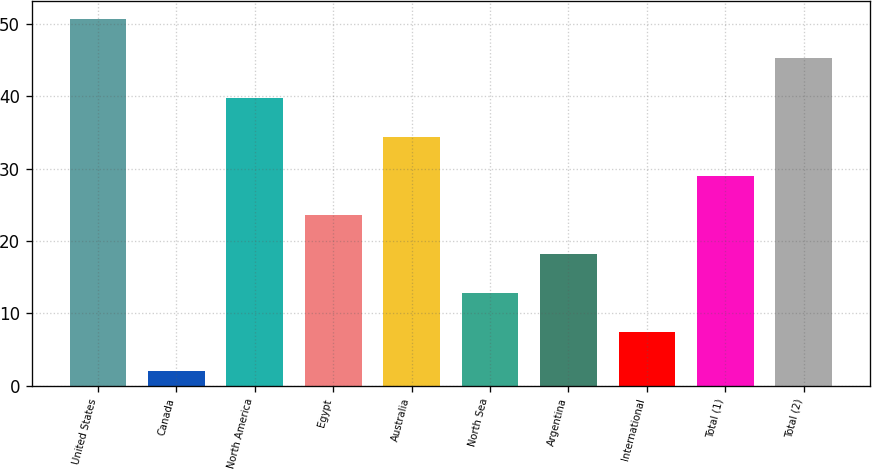Convert chart. <chart><loc_0><loc_0><loc_500><loc_500><bar_chart><fcel>United States<fcel>Canada<fcel>North America<fcel>Egypt<fcel>Australia<fcel>North Sea<fcel>Argentina<fcel>International<fcel>Total (1)<fcel>Total (2)<nl><fcel>50.6<fcel>2<fcel>39.8<fcel>23.6<fcel>34.4<fcel>12.8<fcel>18.2<fcel>7.4<fcel>29<fcel>45.2<nl></chart> 